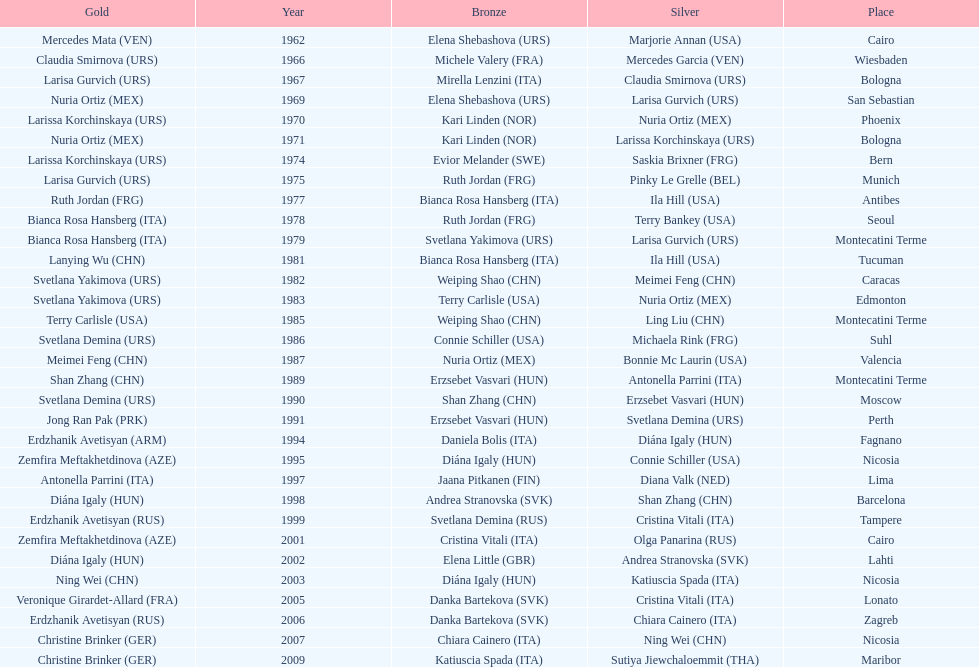Parse the table in full. {'header': ['Gold', 'Year', 'Bronze', 'Silver', 'Place'], 'rows': [['Mercedes Mata\xa0(VEN)', '1962', 'Elena Shebashova\xa0(URS)', 'Marjorie Annan\xa0(USA)', 'Cairo'], ['Claudia Smirnova\xa0(URS)', '1966', 'Michele Valery\xa0(FRA)', 'Mercedes Garcia\xa0(VEN)', 'Wiesbaden'], ['Larisa Gurvich\xa0(URS)', '1967', 'Mirella Lenzini\xa0(ITA)', 'Claudia Smirnova\xa0(URS)', 'Bologna'], ['Nuria Ortiz\xa0(MEX)', '1969', 'Elena Shebashova\xa0(URS)', 'Larisa Gurvich\xa0(URS)', 'San Sebastian'], ['Larissa Korchinskaya\xa0(URS)', '1970', 'Kari Linden\xa0(NOR)', 'Nuria Ortiz\xa0(MEX)', 'Phoenix'], ['Nuria Ortiz\xa0(MEX)', '1971', 'Kari Linden\xa0(NOR)', 'Larissa Korchinskaya\xa0(URS)', 'Bologna'], ['Larissa Korchinskaya\xa0(URS)', '1974', 'Evior Melander\xa0(SWE)', 'Saskia Brixner\xa0(FRG)', 'Bern'], ['Larisa Gurvich\xa0(URS)', '1975', 'Ruth Jordan\xa0(FRG)', 'Pinky Le Grelle\xa0(BEL)', 'Munich'], ['Ruth Jordan\xa0(FRG)', '1977', 'Bianca Rosa Hansberg\xa0(ITA)', 'Ila Hill\xa0(USA)', 'Antibes'], ['Bianca Rosa Hansberg\xa0(ITA)', '1978', 'Ruth Jordan\xa0(FRG)', 'Terry Bankey\xa0(USA)', 'Seoul'], ['Bianca Rosa Hansberg\xa0(ITA)', '1979', 'Svetlana Yakimova\xa0(URS)', 'Larisa Gurvich\xa0(URS)', 'Montecatini Terme'], ['Lanying Wu\xa0(CHN)', '1981', 'Bianca Rosa Hansberg\xa0(ITA)', 'Ila Hill\xa0(USA)', 'Tucuman'], ['Svetlana Yakimova\xa0(URS)', '1982', 'Weiping Shao\xa0(CHN)', 'Meimei Feng\xa0(CHN)', 'Caracas'], ['Svetlana Yakimova\xa0(URS)', '1983', 'Terry Carlisle\xa0(USA)', 'Nuria Ortiz\xa0(MEX)', 'Edmonton'], ['Terry Carlisle\xa0(USA)', '1985', 'Weiping Shao\xa0(CHN)', 'Ling Liu\xa0(CHN)', 'Montecatini Terme'], ['Svetlana Demina\xa0(URS)', '1986', 'Connie Schiller\xa0(USA)', 'Michaela Rink\xa0(FRG)', 'Suhl'], ['Meimei Feng\xa0(CHN)', '1987', 'Nuria Ortiz\xa0(MEX)', 'Bonnie Mc Laurin\xa0(USA)', 'Valencia'], ['Shan Zhang\xa0(CHN)', '1989', 'Erzsebet Vasvari\xa0(HUN)', 'Antonella Parrini\xa0(ITA)', 'Montecatini Terme'], ['Svetlana Demina\xa0(URS)', '1990', 'Shan Zhang\xa0(CHN)', 'Erzsebet Vasvari\xa0(HUN)', 'Moscow'], ['Jong Ran Pak\xa0(PRK)', '1991', 'Erzsebet Vasvari\xa0(HUN)', 'Svetlana Demina\xa0(URS)', 'Perth'], ['Erdzhanik Avetisyan\xa0(ARM)', '1994', 'Daniela Bolis\xa0(ITA)', 'Diána Igaly\xa0(HUN)', 'Fagnano'], ['Zemfira Meftakhetdinova\xa0(AZE)', '1995', 'Diána Igaly\xa0(HUN)', 'Connie Schiller\xa0(USA)', 'Nicosia'], ['Antonella Parrini\xa0(ITA)', '1997', 'Jaana Pitkanen\xa0(FIN)', 'Diana Valk\xa0(NED)', 'Lima'], ['Diána Igaly\xa0(HUN)', '1998', 'Andrea Stranovska\xa0(SVK)', 'Shan Zhang\xa0(CHN)', 'Barcelona'], ['Erdzhanik Avetisyan\xa0(RUS)', '1999', 'Svetlana Demina\xa0(RUS)', 'Cristina Vitali\xa0(ITA)', 'Tampere'], ['Zemfira Meftakhetdinova\xa0(AZE)', '2001', 'Cristina Vitali\xa0(ITA)', 'Olga Panarina\xa0(RUS)', 'Cairo'], ['Diána Igaly\xa0(HUN)', '2002', 'Elena Little\xa0(GBR)', 'Andrea Stranovska\xa0(SVK)', 'Lahti'], ['Ning Wei\xa0(CHN)', '2003', 'Diána Igaly\xa0(HUN)', 'Katiuscia Spada\xa0(ITA)', 'Nicosia'], ['Veronique Girardet-Allard\xa0(FRA)', '2005', 'Danka Bartekova\xa0(SVK)', 'Cristina Vitali\xa0(ITA)', 'Lonato'], ['Erdzhanik Avetisyan\xa0(RUS)', '2006', 'Danka Bartekova\xa0(SVK)', 'Chiara Cainero\xa0(ITA)', 'Zagreb'], ['Christine Brinker\xa0(GER)', '2007', 'Chiara Cainero\xa0(ITA)', 'Ning Wei\xa0(CHN)', 'Nicosia'], ['Christine Brinker\xa0(GER)', '2009', 'Katiuscia Spada\xa0(ITA)', 'Sutiya Jiewchaloemmit\xa0(THA)', 'Maribor']]} What is the total amount of winnings for the united states in gold, silver and bronze? 9. 